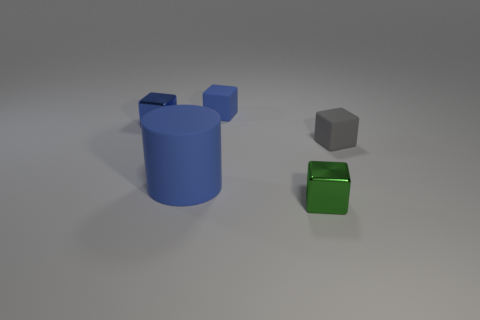There is a tiny thing that is behind the green object and in front of the small blue shiny cube; what shape is it? cube 